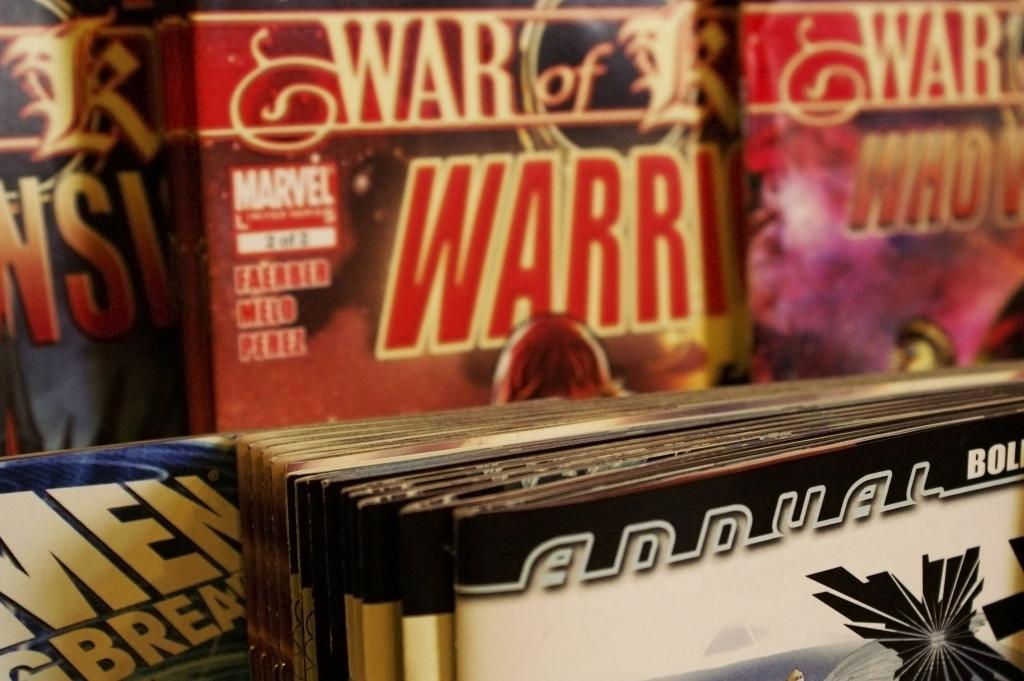<image>
Relay a brief, clear account of the picture shown. A Marvel book designates that it is 2 of 2 in the series. 